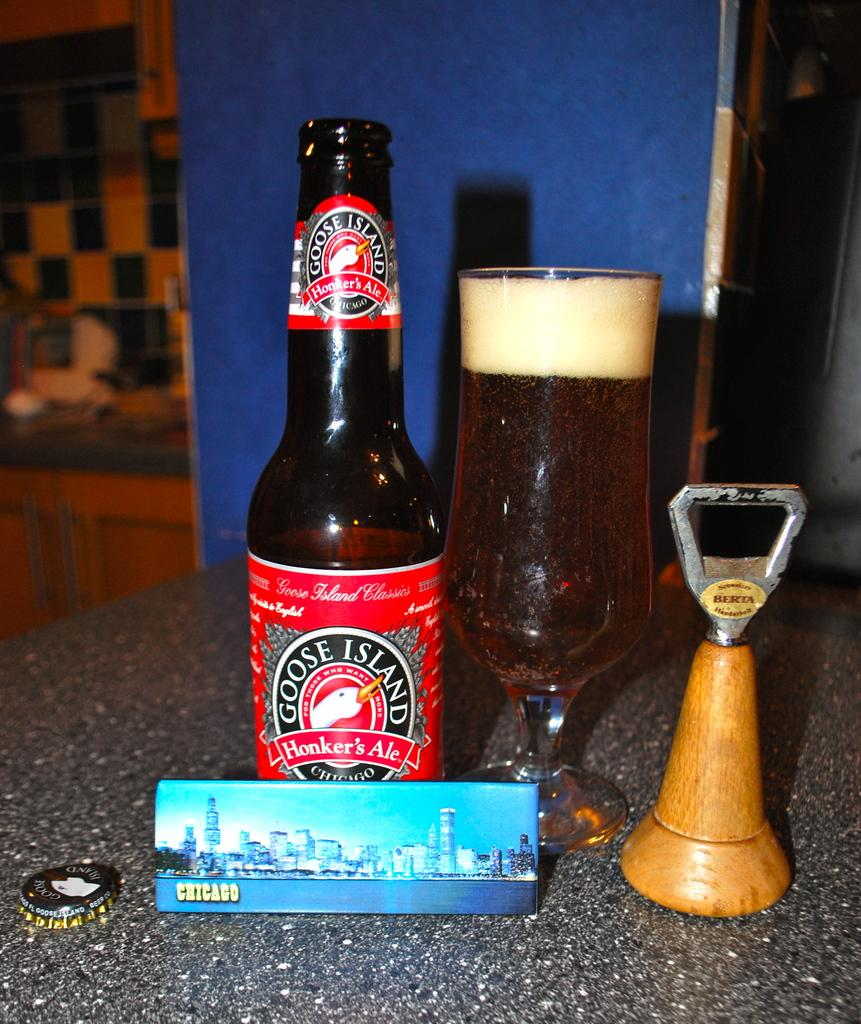<image>
Share a concise interpretation of the image provided. A bottle of Goose Island ale and a foaming glass of beer are on a counter-top along with an old fashioned Berta bottle opener. 